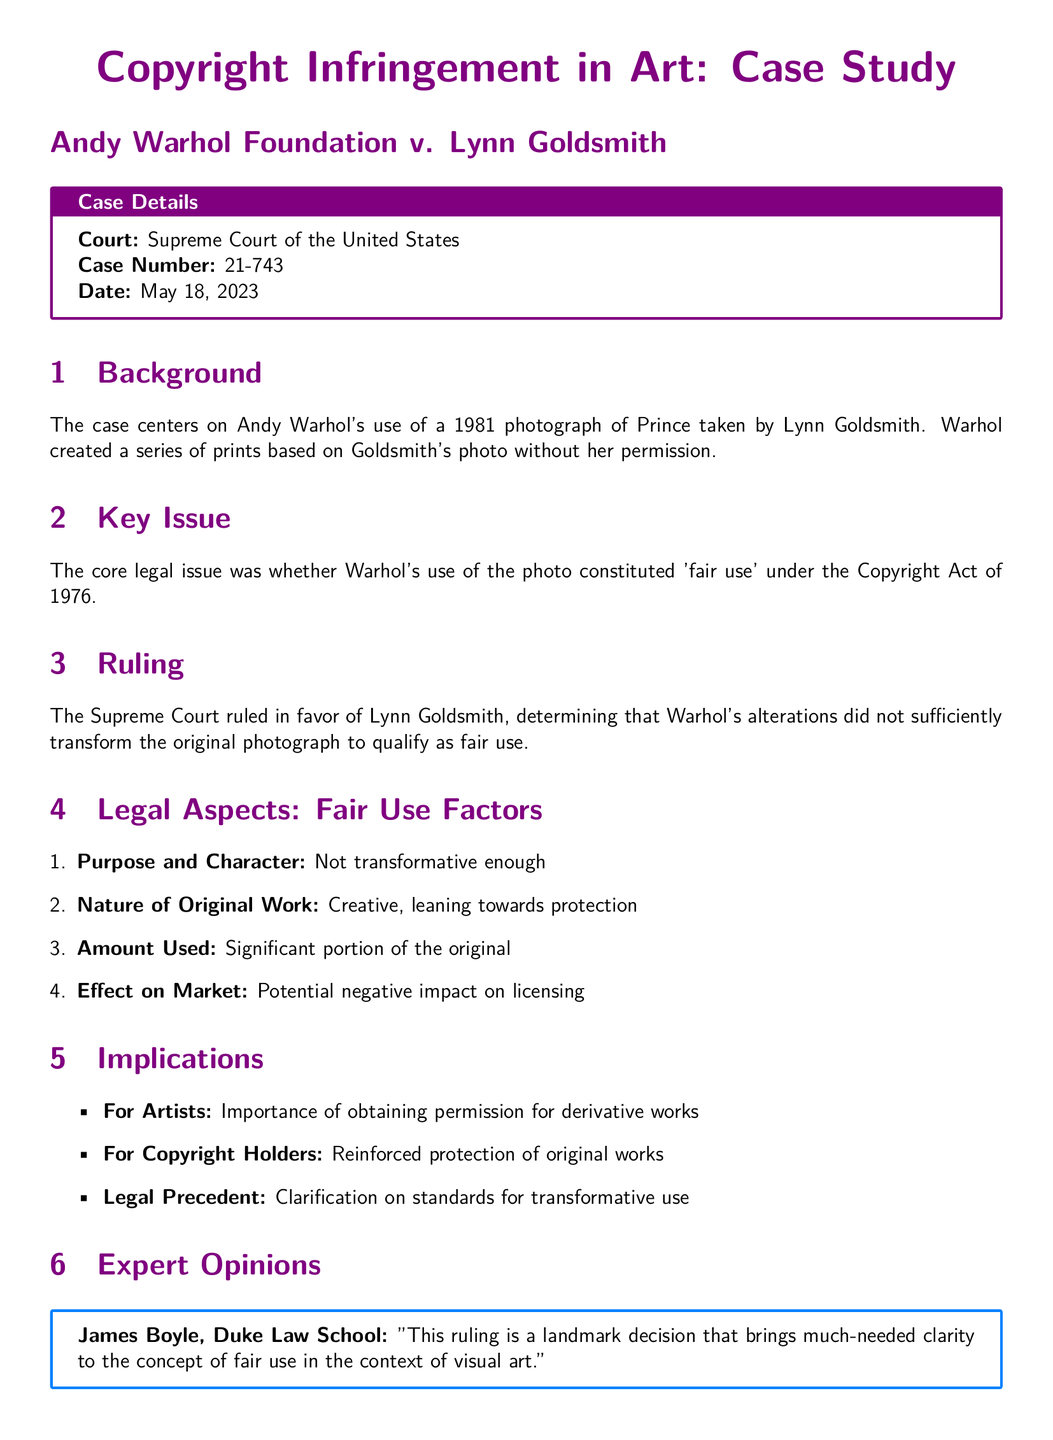What is the case number? The case number is specified in the case details section, which is 21-743.
Answer: 21-743 Which court decided the ruling? The document states that the ruling was made by the Supreme Court of the United States.
Answer: Supreme Court of the United States When was the ruling made? The date of the ruling is provided in the case details section, which is May 18, 2023.
Answer: May 18, 2023 What was the main legal issue in the case? The legal issue pertains to whether Warhol's use of the photo constituted 'fair use' under the Copyright Act of 1976.
Answer: 'Fair use' What is one implication for artists mentioned? The document indicates that artists must obtain permission for derivative works.
Answer: Obtain permission What does the case clarify regarding transformative use? The ruling reinforces the understanding of standards for transformative use.
Answer: Standards for transformative use What did James Boyle comment about the ruling? Boyle described the ruling as a landmark decision that brings clarity to the concept of fair use in visual art.
Answer: Landmark decision How many fair use factors are listed in the document? There are four fair use factors discussed in the document.
Answer: Four What is the nature of the original work as described in the ruling? The document characterizes the original work as creative, leaning towards protection.
Answer: Creative, leaning towards protection 